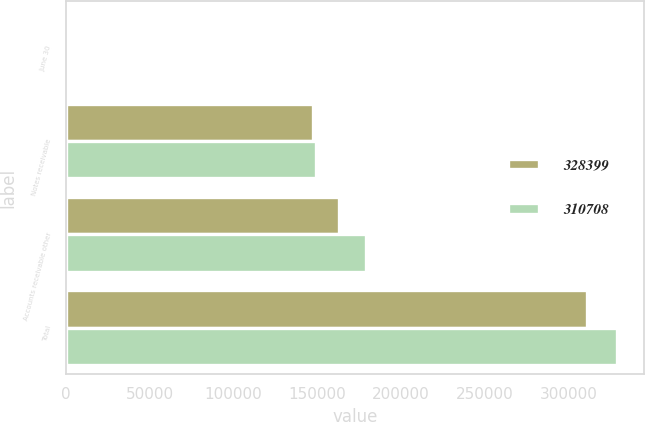Convert chart to OTSL. <chart><loc_0><loc_0><loc_500><loc_500><stacked_bar_chart><ecel><fcel>June 30<fcel>Notes receivable<fcel>Accounts receivable other<fcel>Total<nl><fcel>328399<fcel>2019<fcel>147719<fcel>162989<fcel>310708<nl><fcel>310708<fcel>2018<fcel>149254<fcel>179145<fcel>328399<nl></chart> 